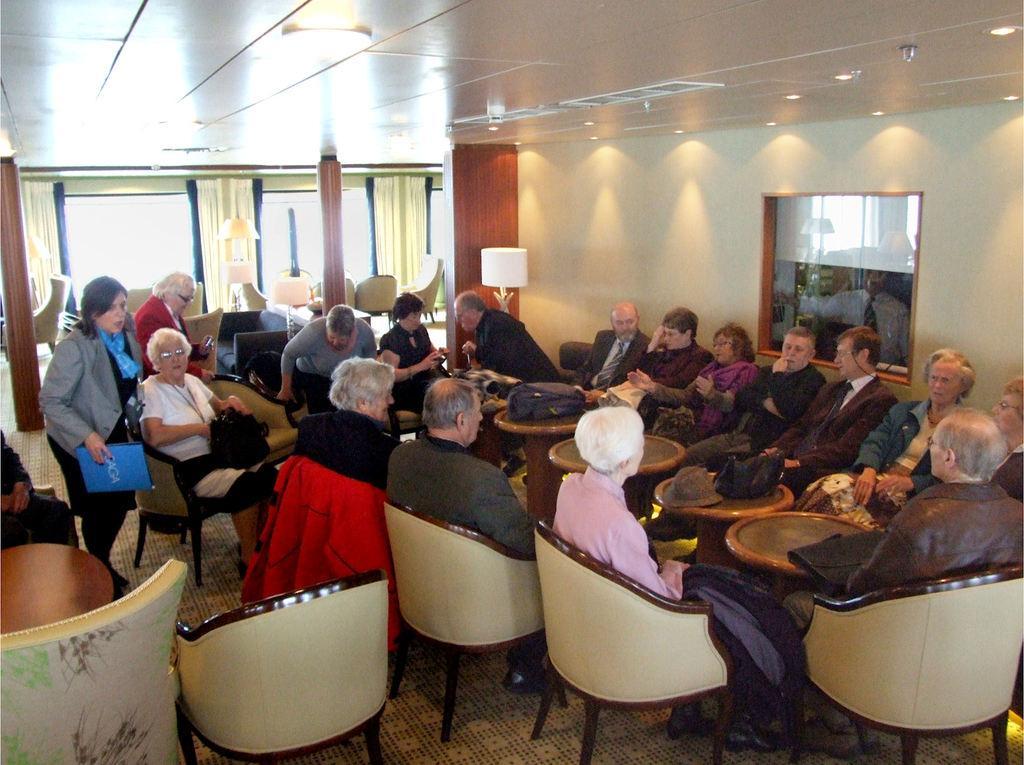Please provide a concise description of this image. In this picture we can see a group of people some are sitting on chair and some are standing and in front of them there is table and we have jackets on chairs and in background we can see windows, curtains, pillar, wall. 